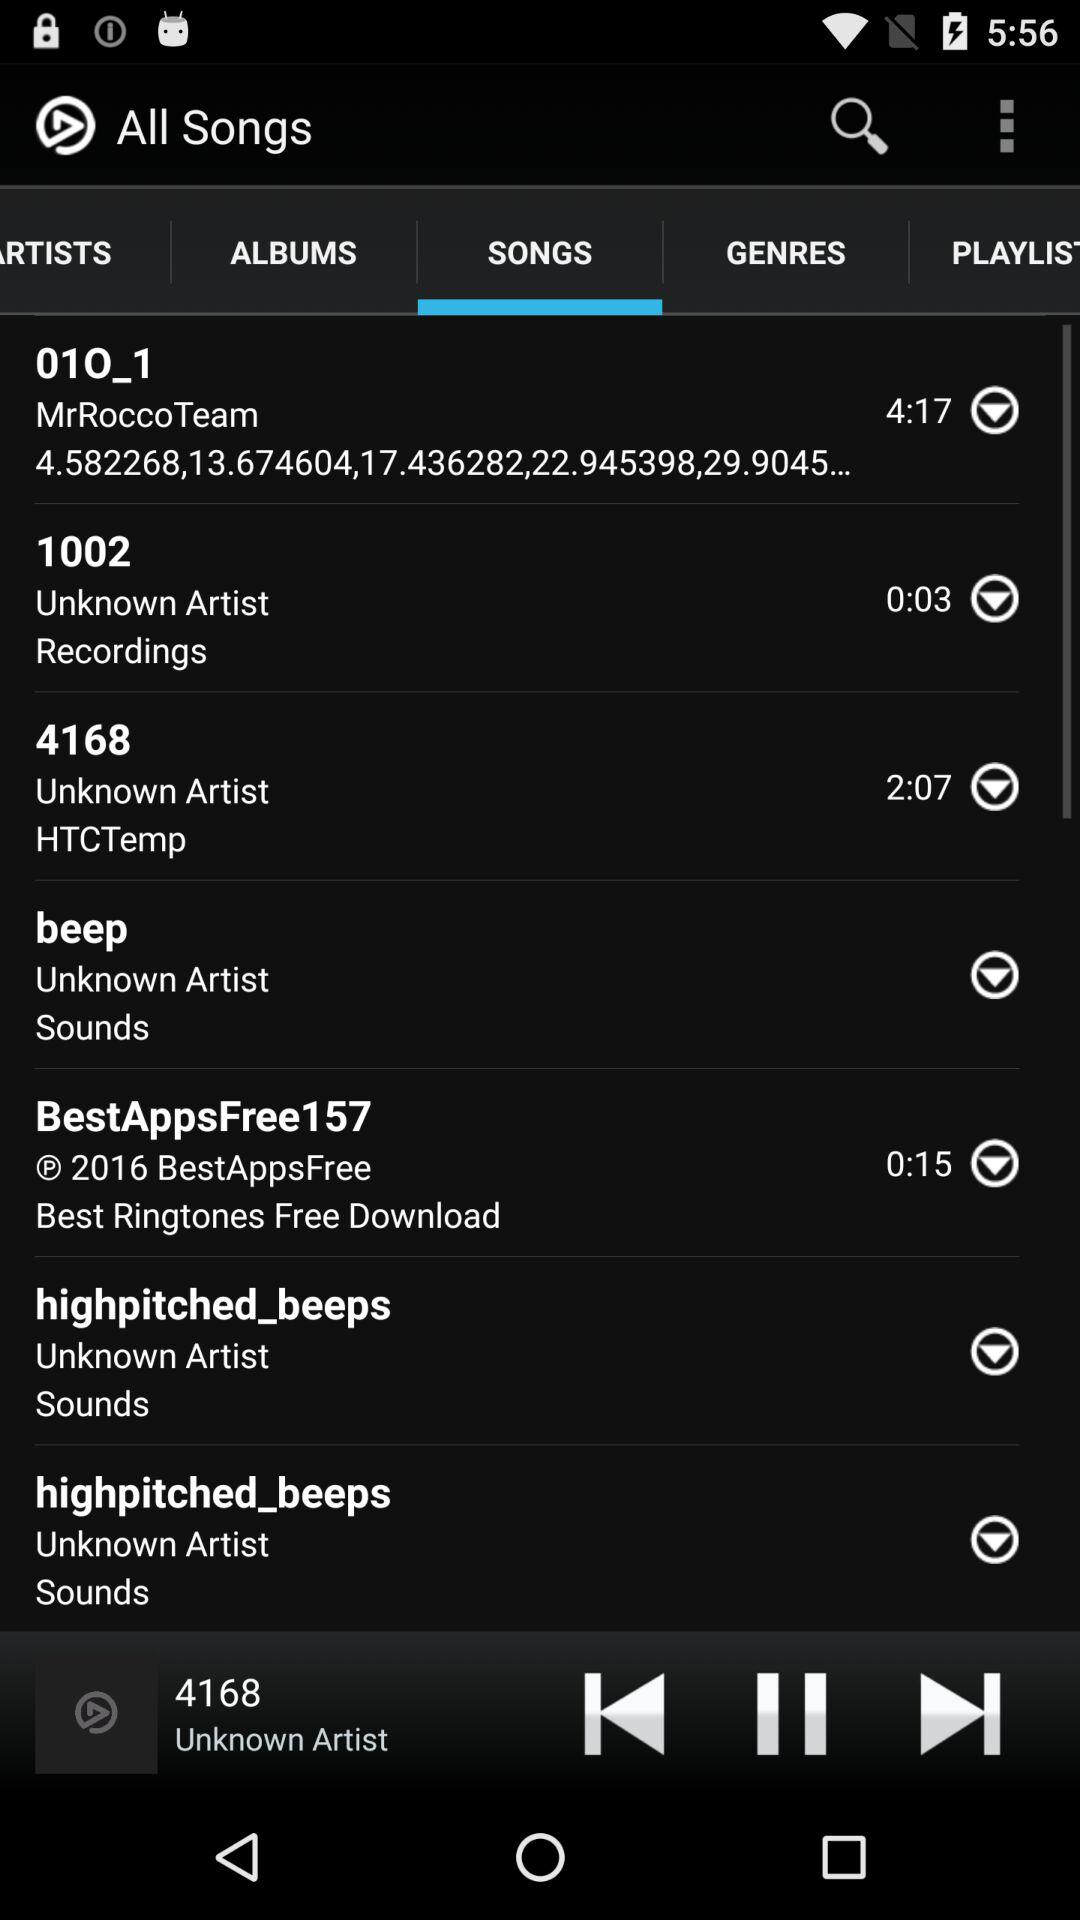What is the application name?
When the provided information is insufficient, respond with <no answer>. <no answer> 